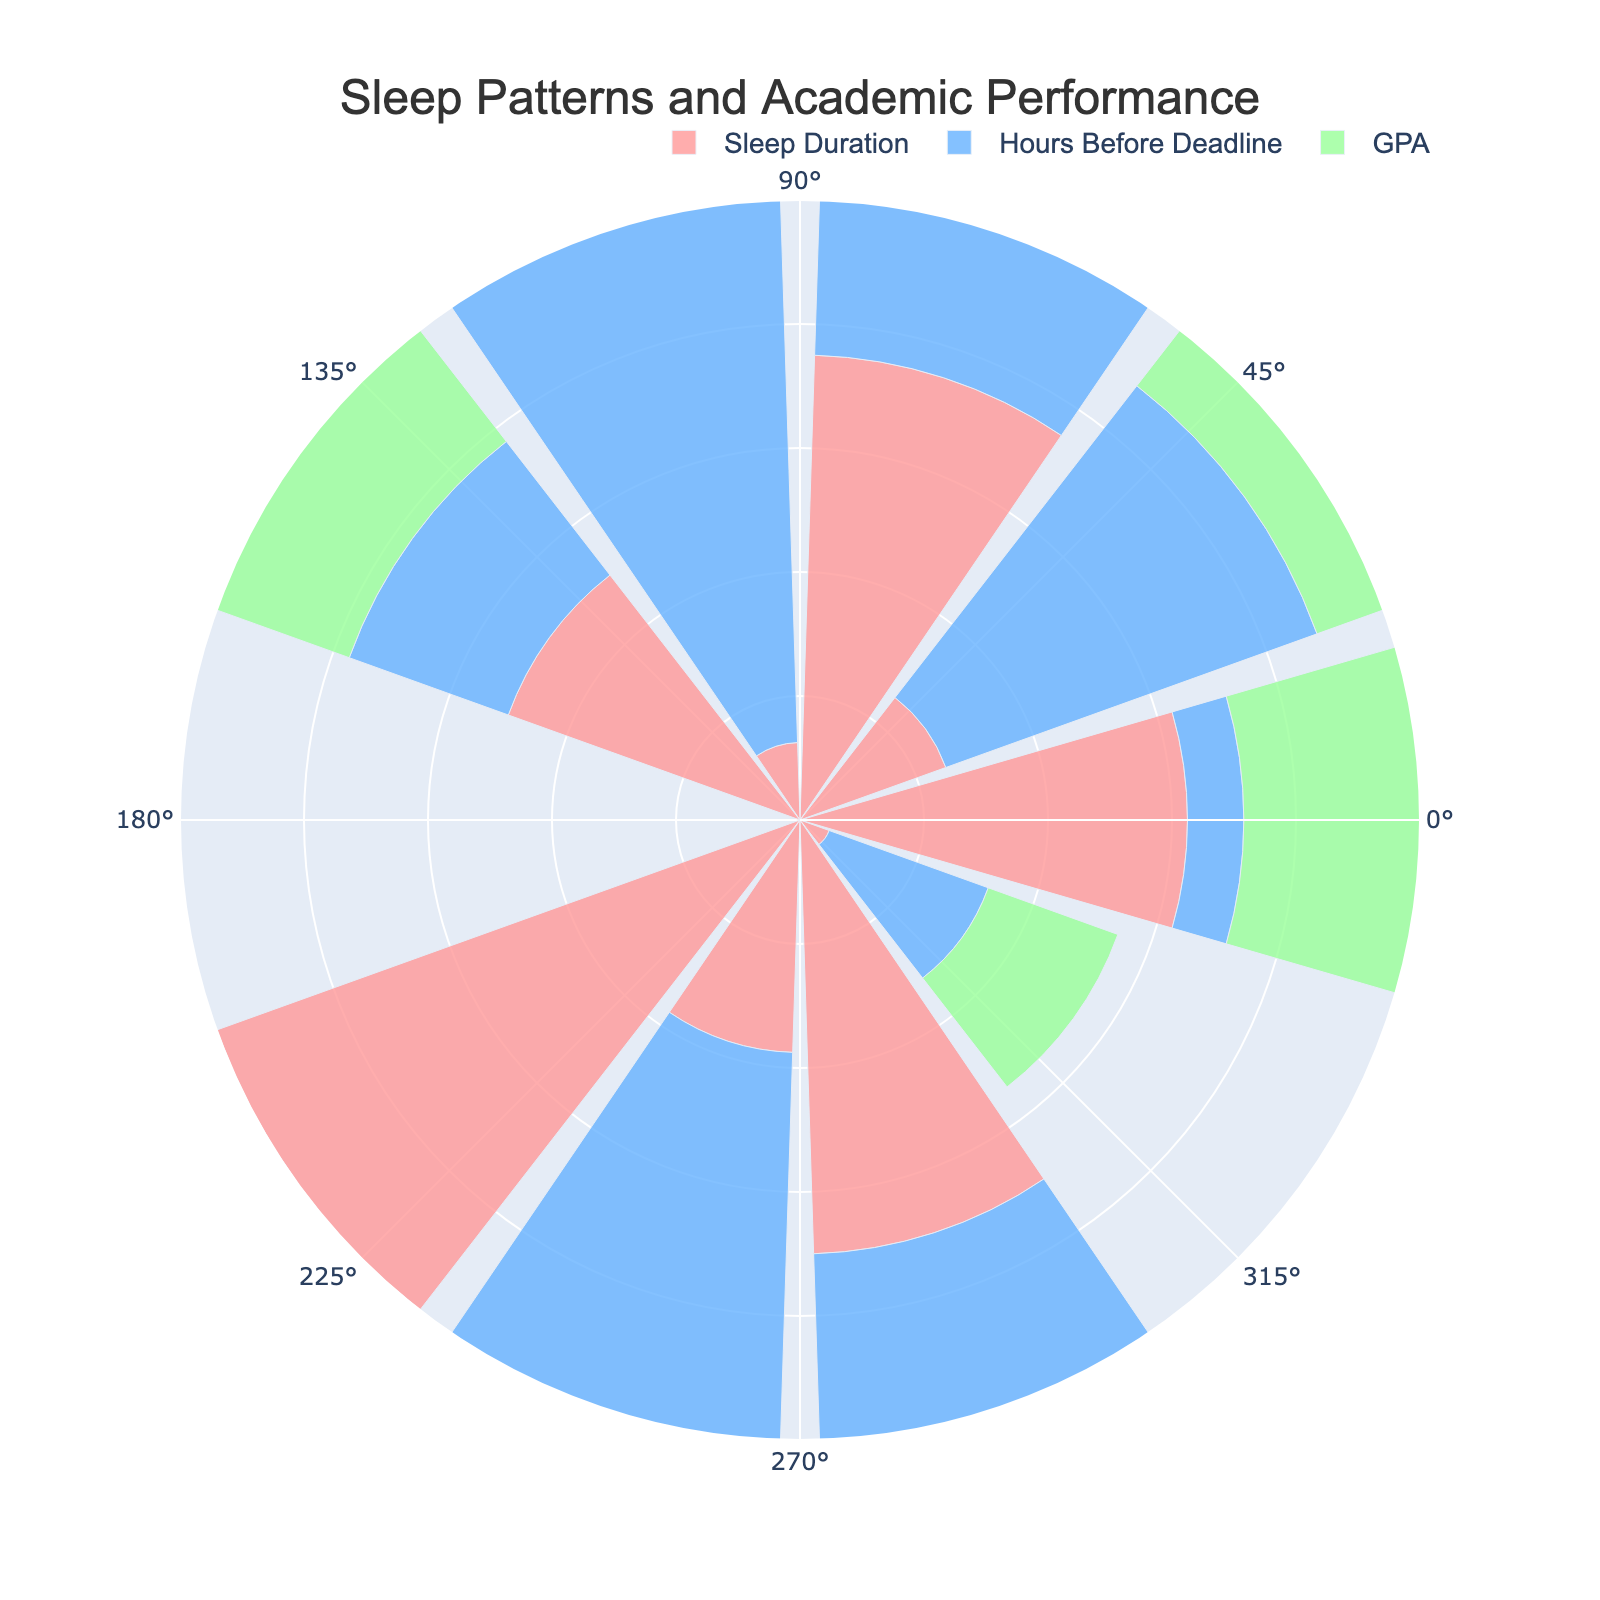What is the title of the figure? The title is displayed at the top center of the figure. It reads "Sleep Patterns and Academic Performance".
Answer: Sleep Patterns and Academic Performance How many different data groups are displayed on the rose chart? The rose chart has three different data groups, which can be identified by their respective colors and labels in the legend.
Answer: Three What color represents 'Sleep Duration' in the rose chart? The color representing 'Sleep Duration' is a light pink, which is indicated in the legend.
Answer: Light pink Which data group has the highest normalized value on average? By visually comparing the lengths of the bars for each group, the 'GPA' group (green) seems to have the highest normalized values.
Answer: GPA Considering the data point with the highest normalized 'Sleep Duration', what is its normalized 'GPA'? The bar length for the highest 'Sleep Duration' (light pink) approximates to its corresponding green bar for 'GPA', which has a normalized value close to 1.
Answer: Approximately 1 How do 'Hours Before Deadline' and 'GPA' generally compare visually? Visually, 'Hours Before Deadline' (blue) and 'GPA' (green) bars show that 'GPA' values are generally higher than 'Hours Before Deadline'
Answer: GPA values are higher than Hours Before Deadline Find the difference between the highest ‘Sleep Duration’ and the highest ‘Hours Before Deadline’. Locate the longest bar for 'Sleep Duration' (about 1) and the longest bar for 'Hours Before Deadline' (close to 0.67), then calculate the difference: 1 - 0.67.
Answer: 0.33 Is there a clear correlation between high 'Sleep Duration' and high 'GPA' based on the visualization? High 'Sleep Duration' bars (pink) often coincide with high 'GPA' bars (green), suggesting a positive correlation.
Answer: Yes What normalized value range corresponds to the radial axis in the rose chart? The radial axis is marked from 0 to 1, indicating the range of normalized values.
Answer: 0 to 1 